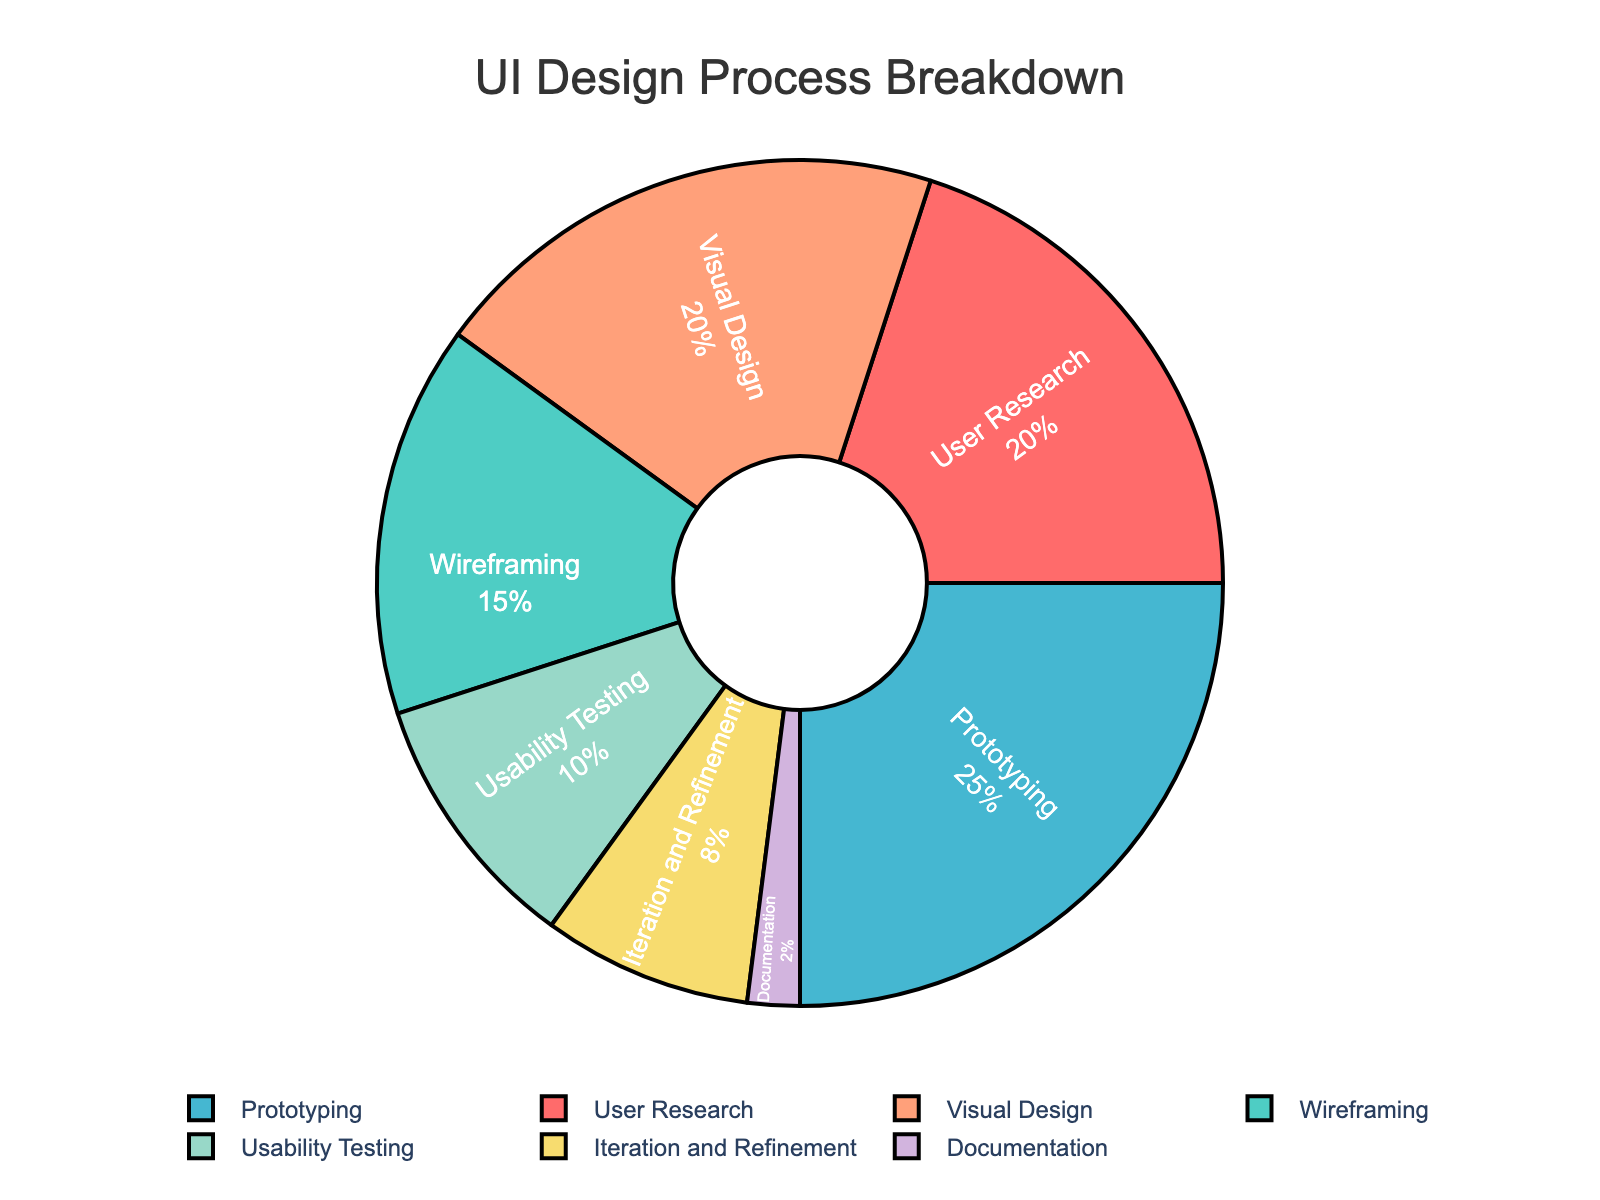What phase takes up the smallest percentage of the UI design process? We look at the pie chart and identify that the phase with the smallest slice is "Documentation". This phase only takes up 2% of the total time.
Answer: Documentation What percentage of time is spent on User Research and Visual Design combined? The percentages for User Research and Visual Design are 20% and 20% respectively. Adding them together: 20% + 20% = 40%.
Answer: 40% Which phase occupies a greater percentage of the UI design process: Wireframing or Iteration and Refinement? We compare the percentages of Wireframing (15%) and Iteration and Refinement (8%). Since 15% is greater than 8%, Wireframing occupies a greater percentage.
Answer: Wireframing What is the difference in percentage between Prototyping and Usability Testing? We find Prototyping is 25% and Usability Testing is 10%. Calculating the difference: 25% - 10% = 15%.
Answer: 15% Which color represents the Visual Design phase in the pie chart? Visual Design is represented in the legend with a corresponding color. By observing the chart, we see Visual Design is marked with the color red.
Answer: Red What percentage of time is spent on phases other than Prototyping? The total percentage is 100%. Prototyping takes up 25%, so the time spent on other phases is 100% - 25% = 75%.
Answer: 75% Rank the phases from highest to lowest based on the percentage of time spent. By examining the chart, we list the phases in descending order: Prototyping (25%), User Research (20%), Visual Design (20%), Wireframing (15%), Usability Testing (10%), Iteration and Refinement (8%), Documentation (2%).
Answer: Prototyping, User Research, Visual Design, Wireframing, Usability Testing, Iteration and Refinement, Documentation If we double the time spent on Iteration and Refinement, what would be its new percentage? Original percentage for Iteration and Refinement is 8%. Doubling it: 8% * 2 = 16%.
Answer: 16% What is the average percentage of time spent on User Research, Wireframing, and Visual Design? The percentages are User Research (20%), Wireframing (15%), and Visual Design (20%). Calculating the average: (20% + 15% + 20%) / 3 = 18.33%.
Answer: 18.33% How many phases have a percentage greater than 10%? From the chart, we can see the phases: User Research (20%), Wireframing (15%), Prototyping (25%), and Visual Design (20%) each have percentages greater than 10%. That's four phases.
Answer: Four 